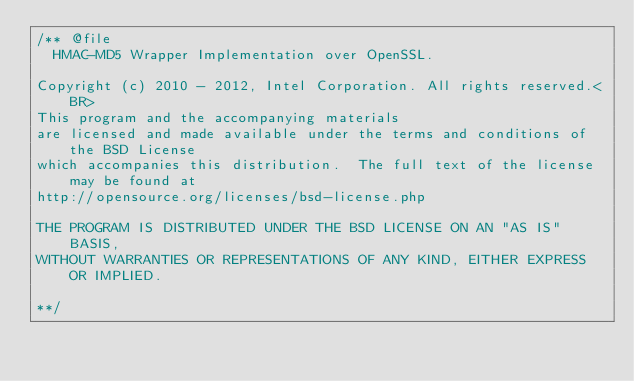Convert code to text. <code><loc_0><loc_0><loc_500><loc_500><_C_>/** @file
  HMAC-MD5 Wrapper Implementation over OpenSSL.

Copyright (c) 2010 - 2012, Intel Corporation. All rights reserved.<BR>
This program and the accompanying materials
are licensed and made available under the terms and conditions of the BSD License
which accompanies this distribution.  The full text of the license may be found at
http://opensource.org/licenses/bsd-license.php

THE PROGRAM IS DISTRIBUTED UNDER THE BSD LICENSE ON AN "AS IS" BASIS,
WITHOUT WARRANTIES OR REPRESENTATIONS OF ANY KIND, EITHER EXPRESS OR IMPLIED.

**/
</code> 